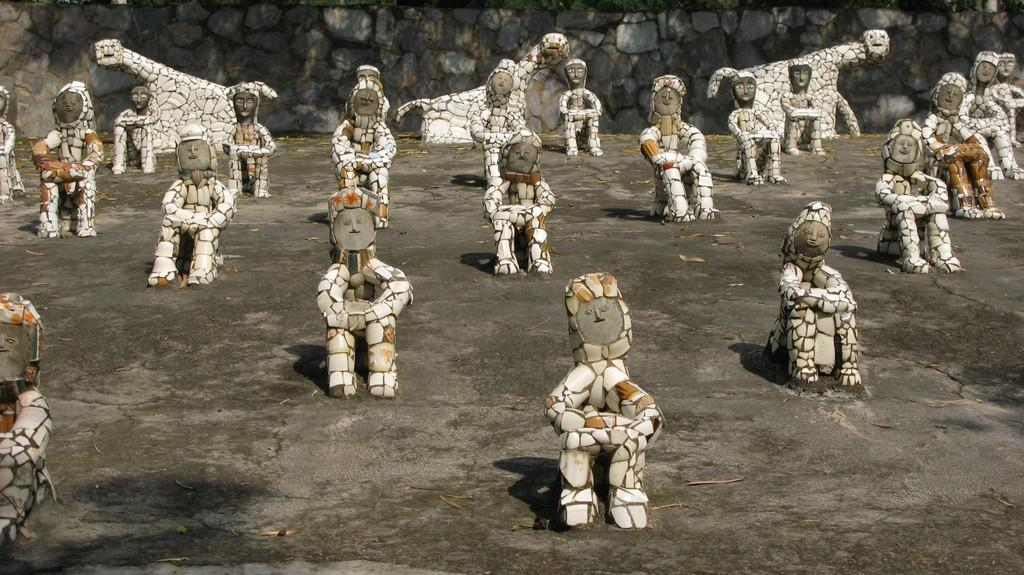What can be seen in the image? There are statues in the image. Where are the statues located? The statues are on a surface. What can be seen in the background of the image? There is a stone wall in the background of the image. What type of poison is being used to attack the statues in the image? There is no poison or attack present in the image; it simply features statues on a surface with a stone wall in the background. 